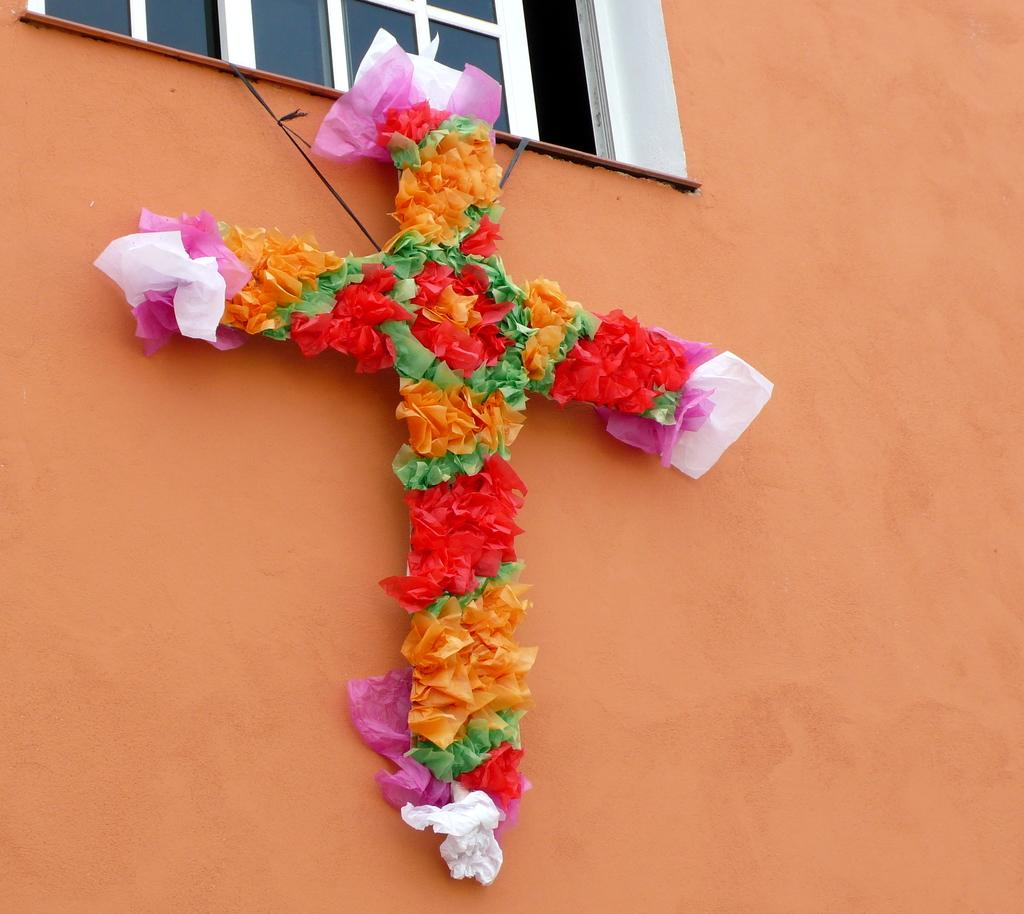What type of handicraft is displayed on the wall in the image? There is a handicraft of a cross symbol on the wall. Can you describe any architectural features in the image? There is a window visible in the image. What type of educational scene is depicted in the image? There is no educational scene depicted in the image; it only features a handicraft of a cross symbol on the wall and a window. 